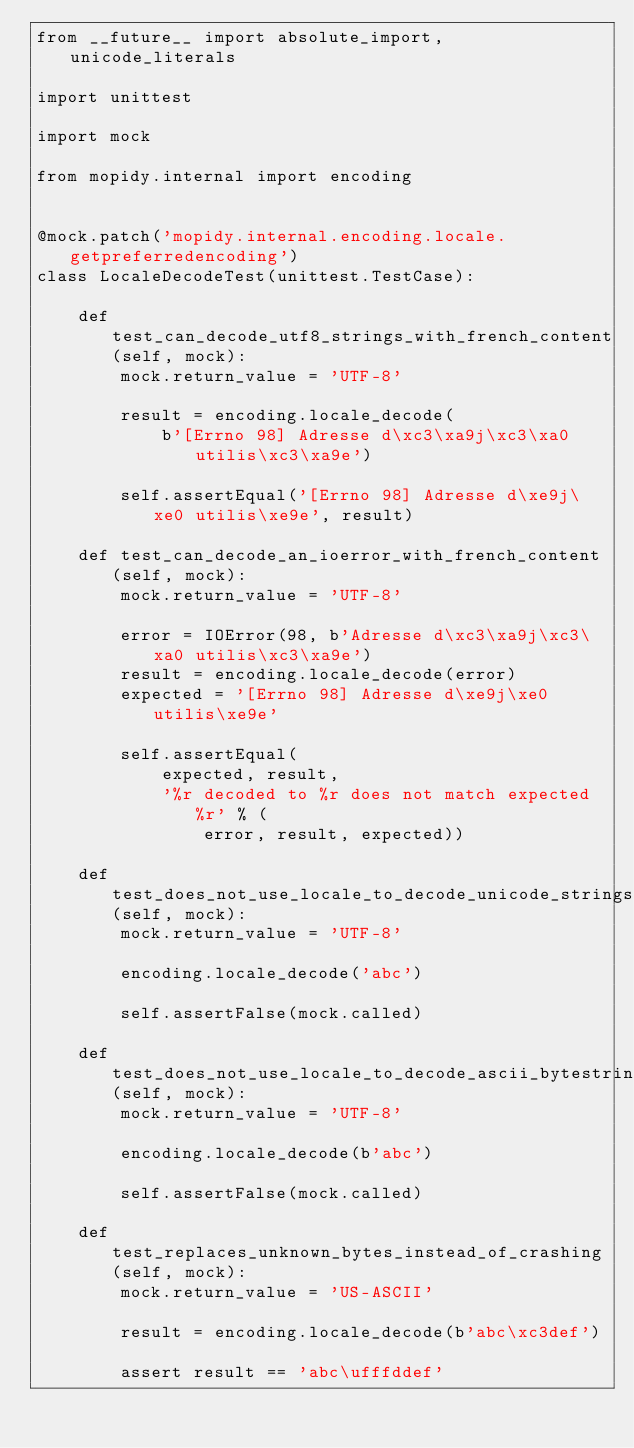Convert code to text. <code><loc_0><loc_0><loc_500><loc_500><_Python_>from __future__ import absolute_import, unicode_literals

import unittest

import mock

from mopidy.internal import encoding


@mock.patch('mopidy.internal.encoding.locale.getpreferredencoding')
class LocaleDecodeTest(unittest.TestCase):

    def test_can_decode_utf8_strings_with_french_content(self, mock):
        mock.return_value = 'UTF-8'

        result = encoding.locale_decode(
            b'[Errno 98] Adresse d\xc3\xa9j\xc3\xa0 utilis\xc3\xa9e')

        self.assertEqual('[Errno 98] Adresse d\xe9j\xe0 utilis\xe9e', result)

    def test_can_decode_an_ioerror_with_french_content(self, mock):
        mock.return_value = 'UTF-8'

        error = IOError(98, b'Adresse d\xc3\xa9j\xc3\xa0 utilis\xc3\xa9e')
        result = encoding.locale_decode(error)
        expected = '[Errno 98] Adresse d\xe9j\xe0 utilis\xe9e'

        self.assertEqual(
            expected, result,
            '%r decoded to %r does not match expected %r' % (
                error, result, expected))

    def test_does_not_use_locale_to_decode_unicode_strings(self, mock):
        mock.return_value = 'UTF-8'

        encoding.locale_decode('abc')

        self.assertFalse(mock.called)

    def test_does_not_use_locale_to_decode_ascii_bytestrings(self, mock):
        mock.return_value = 'UTF-8'

        encoding.locale_decode(b'abc')

        self.assertFalse(mock.called)

    def test_replaces_unknown_bytes_instead_of_crashing(self, mock):
        mock.return_value = 'US-ASCII'

        result = encoding.locale_decode(b'abc\xc3def')

        assert result == 'abc\ufffddef'
</code> 